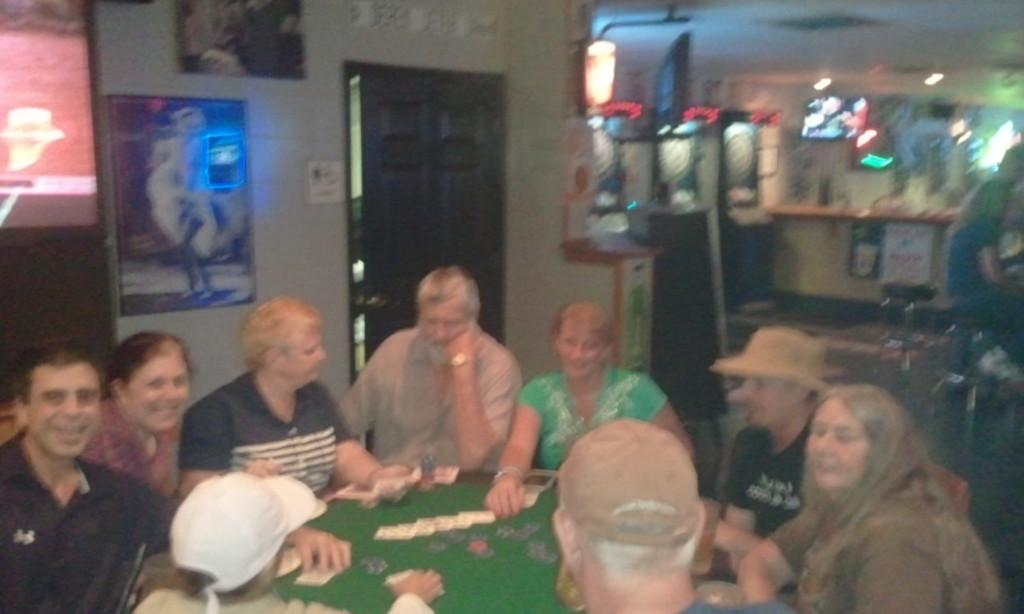What is happening with the group of people in the image? The people are seated on chairs and playing a game on a table. What can be seen on the wall in the image? There are photo frames on the wall. Is there any entrance or exit visible in the image? Yes, there is a door visible in the image. What statement can be made about the size of the table in the image? There is no information provided about the size of the table in the image, so it cannot be determined. 